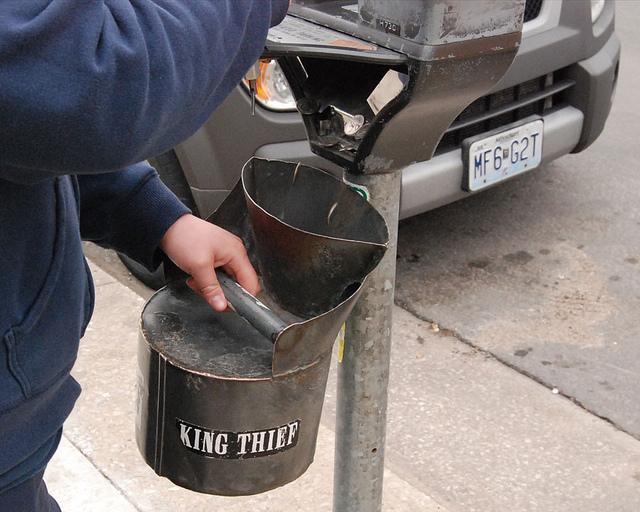Is this person emptying a parking meter?
Short answer required. Yes. Is this likely to be a bad person?
Give a very brief answer. No. What does the sticker on his can say?
Give a very brief answer. King thief. 